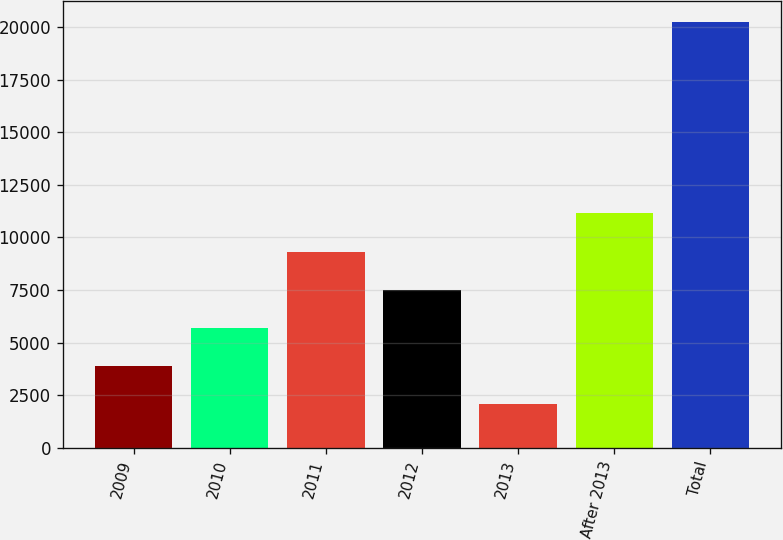<chart> <loc_0><loc_0><loc_500><loc_500><bar_chart><fcel>2009<fcel>2010<fcel>2011<fcel>2012<fcel>2013<fcel>After 2013<fcel>Total<nl><fcel>3877<fcel>5694<fcel>9328<fcel>7511<fcel>2060<fcel>11145<fcel>20230<nl></chart> 